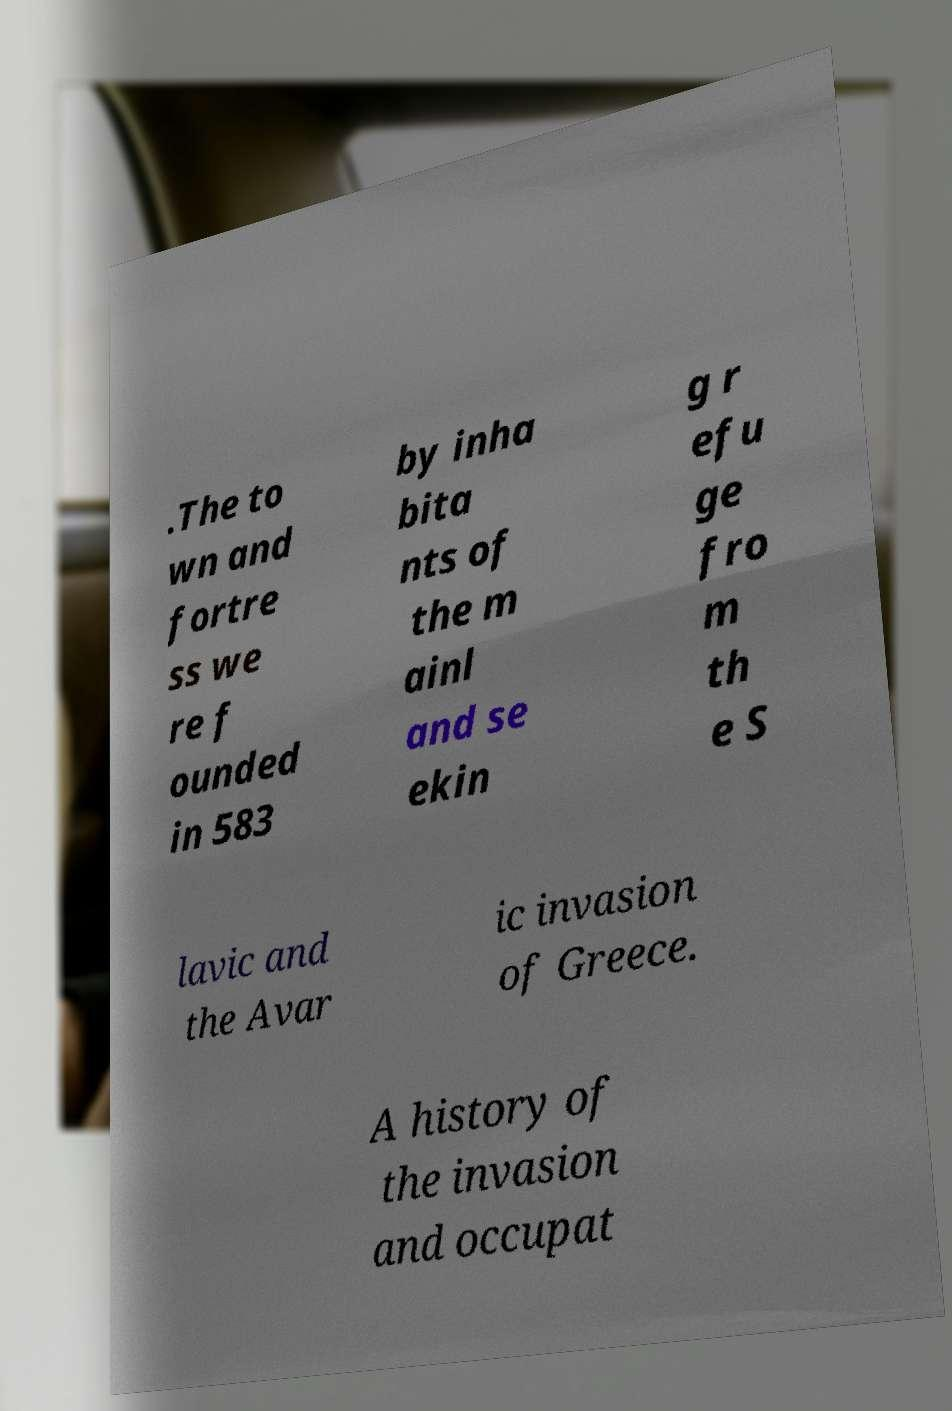There's text embedded in this image that I need extracted. Can you transcribe it verbatim? .The to wn and fortre ss we re f ounded in 583 by inha bita nts of the m ainl and se ekin g r efu ge fro m th e S lavic and the Avar ic invasion of Greece. A history of the invasion and occupat 